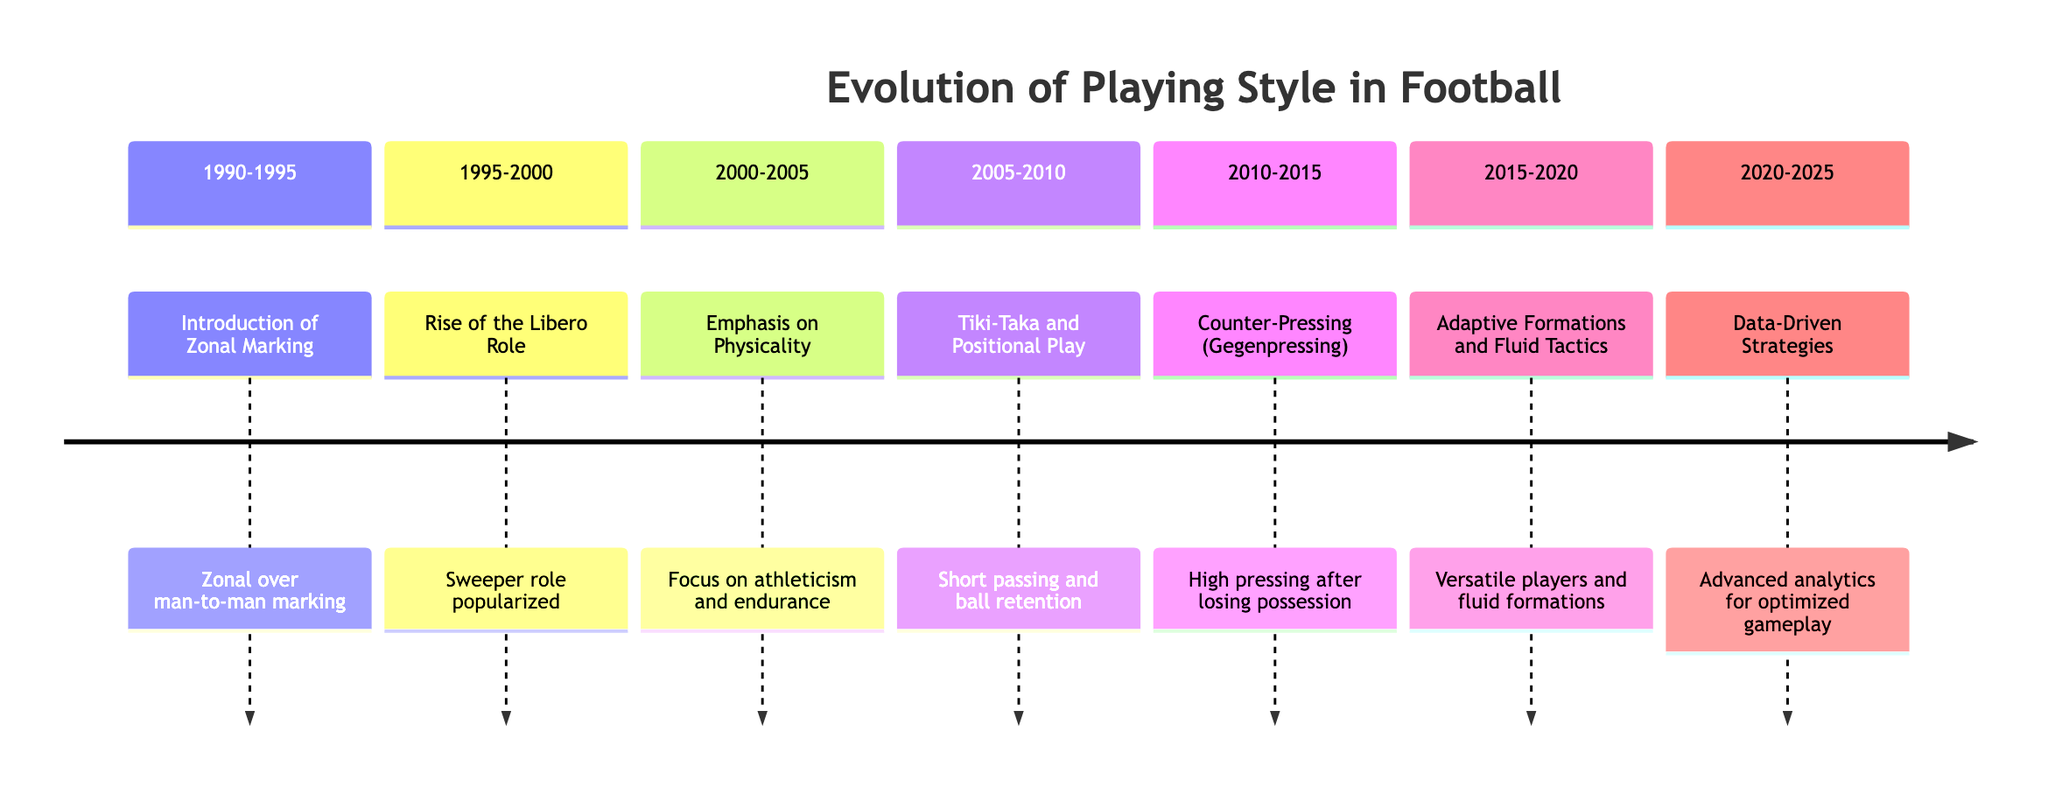What is the playing style change from 1990-1995? The diagram indicates that the playing style change during 1990-1995 was the introduction of zonal marking, which is highlighted as a key defensive strategy in that time period.
Answer: Introduction of Zonal Marking How many distinct playing style changes are represented in the timeline? By counting each season listed in the timeline, there are a total of 7 distinct playing style changes represented from 1990 to 2025.
Answer: 7 Which playing style emphasizes high pressing immediately after losing possession? The timeline specifies that the style which emphasizes high pressing after losing possession is called counter-pressing, also known as gegenpressing, occurring during the 2010-2015 season.
Answer: Counter-Pressing (Gegenpressing) What transition occurs in the playing style from 2005-2010 to 2010-2015? The transition reflects a shift from tiki-taka and positional play, which focused on short passing and ball retention, to counter-pressing, which concentrated on quickly regaining possession after losing the ball.
Answer: From tiki-taka to counter-pressing Which season saw the introduction of data-driven strategies? According to the timeline, data-driven strategies were introduced in the 2020-2025 season, marking a significant evolution influenced by analytics and technology.
Answer: 2020-2025 Who popularized the libero role during 1995-2000? The diagram notes that the role of libero was popularized by Franco Baresi during the specified season of 1995-2000, indicating an influential figure in that change.
Answer: Franco Baresi What does the playing style change from 2015-2020 entail? The playing style from 2015-2020 is characterized by adaptive formations and fluid tactics, enabling players to take on multiple roles and responsibilities within the match.
Answer: Adaptive Formations and Fluid Tactics 